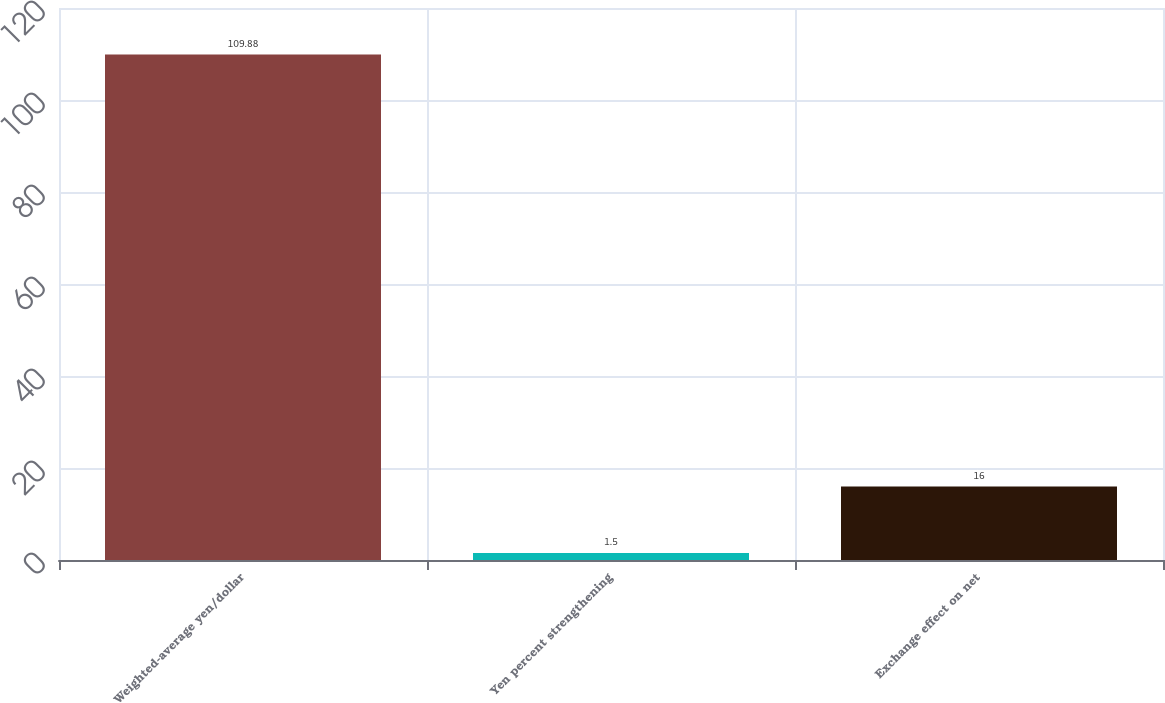Convert chart. <chart><loc_0><loc_0><loc_500><loc_500><bar_chart><fcel>Weighted-average yen/dollar<fcel>Yen percent strengthening<fcel>Exchange effect on net<nl><fcel>109.88<fcel>1.5<fcel>16<nl></chart> 